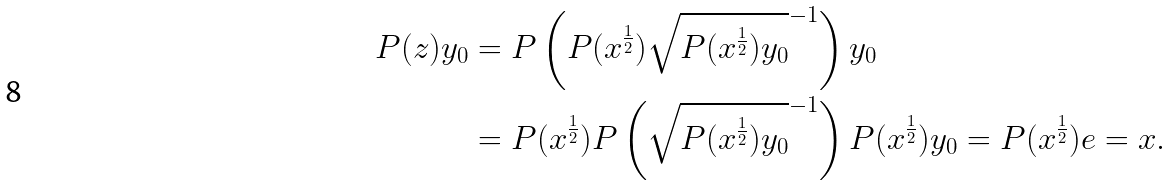<formula> <loc_0><loc_0><loc_500><loc_500>P ( z ) y _ { 0 } & = P \left ( P ( x ^ { \frac { 1 } { 2 } } ) \sqrt { P ( x ^ { \frac { 1 } { 2 } } ) y _ { 0 } } ^ { - 1 } \right ) y _ { 0 } \\ & = P ( x ^ { \frac { 1 } { 2 } } ) P \left ( \sqrt { P ( x ^ { \frac { 1 } { 2 } } ) y _ { 0 } } ^ { - 1 } \right ) P ( x ^ { \frac { 1 } { 2 } } ) y _ { 0 } = P ( x ^ { \frac { 1 } { 2 } } ) e = x .</formula> 